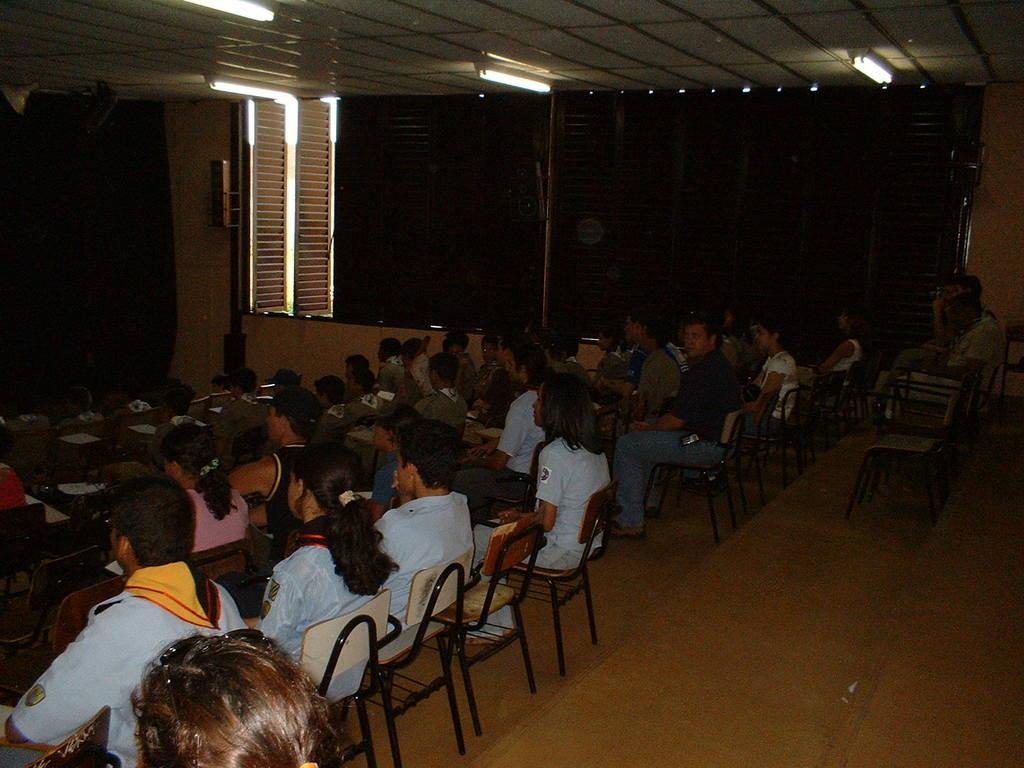What are the people in the image doing? There are many people sitting on chairs in the image. What can be seen in the background of the image? There are windows in the background. What type of lighting is present in the image? There are tube lights on the ceiling. What type of record is being played in the image? There is no record or music player present in the image. How many spoons are visible in the image? There is no mention of spoons in the provided facts, so we cannot determine if any are visible in the image. 